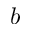<formula> <loc_0><loc_0><loc_500><loc_500>b</formula> 